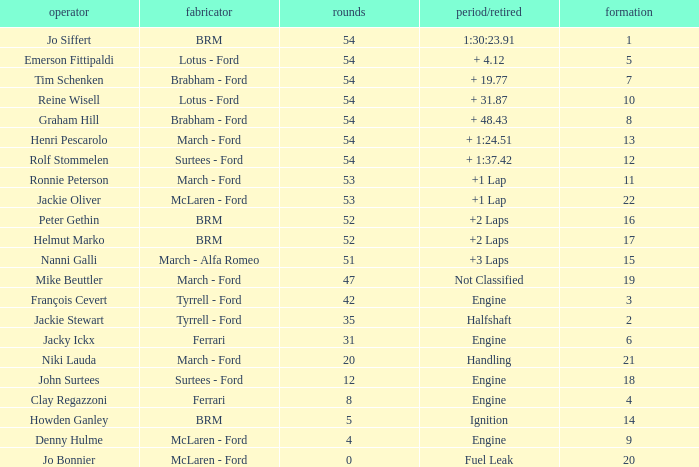What is the low grid that has brm and over 54 laps? None. 